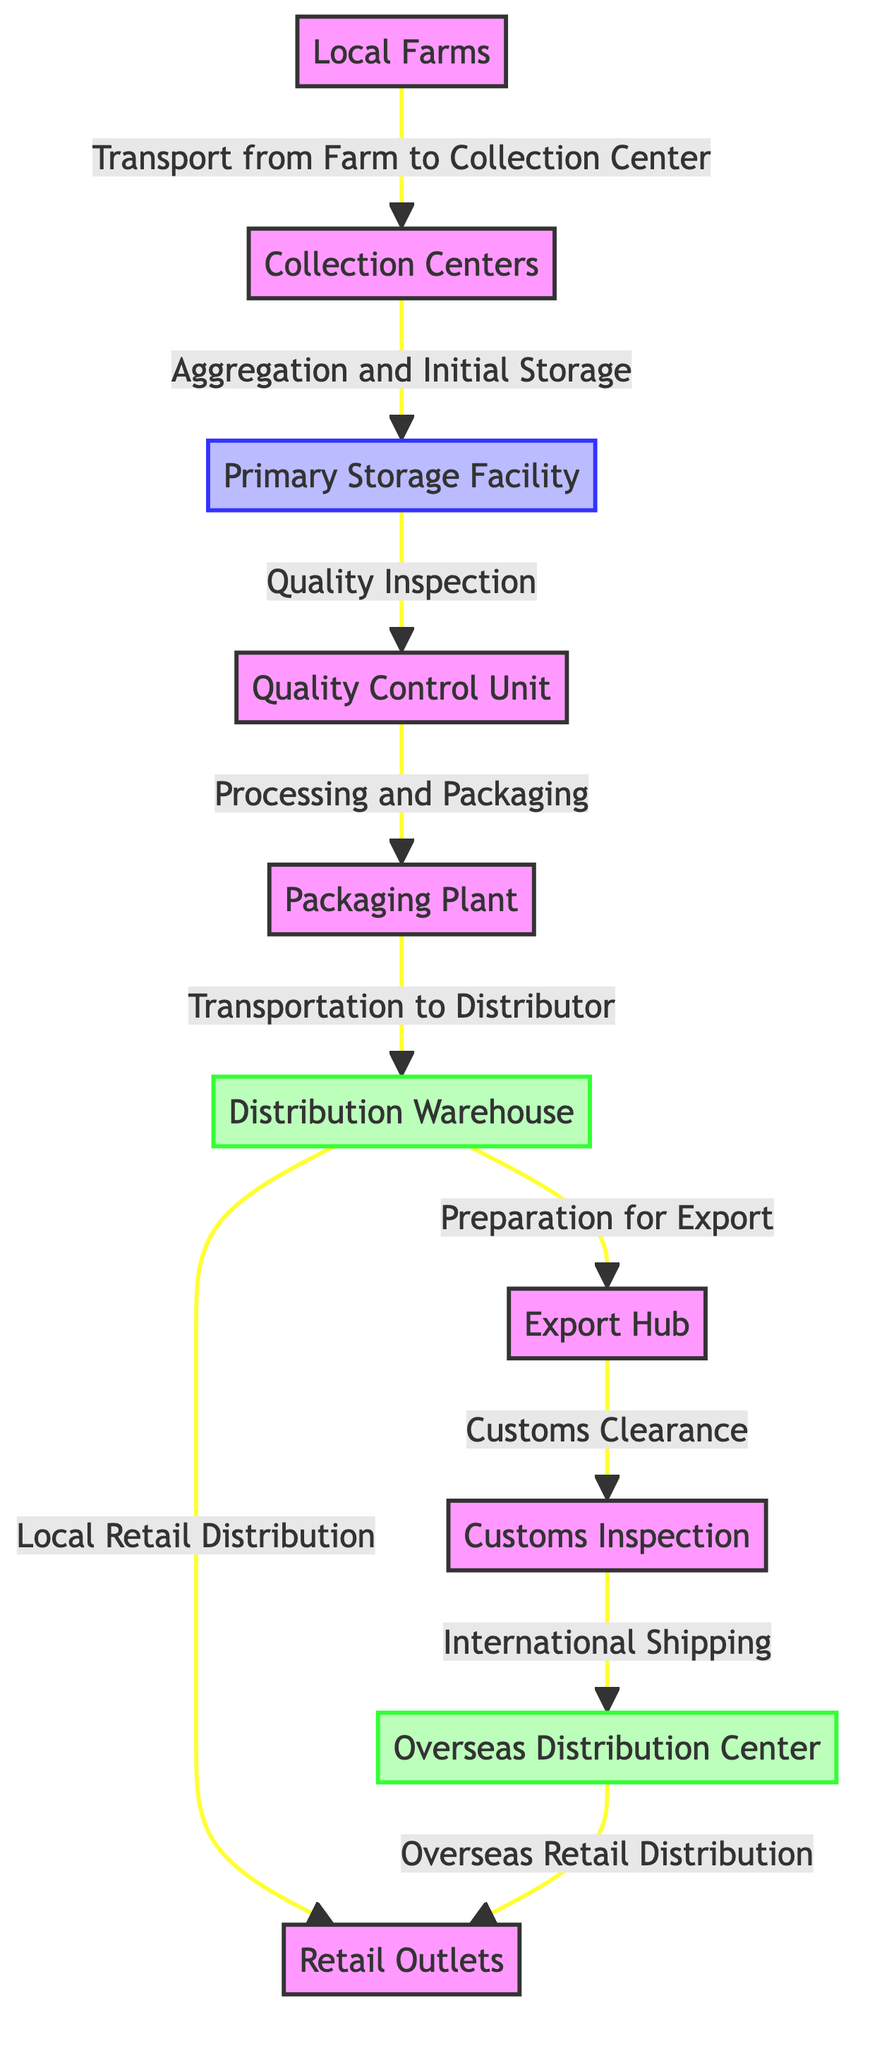What is the first node in the flow? The diagram starts at the first node labeled "Local Farms," which is where the sourcing of tropical fruits begins.
Answer: Local Farms How many nodes are in the diagram? By counting all the distinct locations listed in the diagram, there are a total of ten nodes present.
Answer: 10 What type of facility is the Primary Storage Facility? The Primary Storage Facility is categorized as a storage facility, which is indicated by the specific styling applied to that node in the diagram.
Answer: Storage Which node follows the Quality Control Unit? After the Quality Control Unit, the next node in the flow is the Packaging Plant, indicating that products are then processed for packaging.
Answer: Packaging Plant What is the relationship between the Distribution Warehouse and the Retail Outlets? The relationship shows that the Distribution Warehouse leads directly to Local Retail Distribution, supplying the Retail Outlets with products.
Answer: Local Retail Distribution Which two nodes connect to the Distribution Warehouse? The Distribution Warehouse receives products from the Packaging Plant and also sends products to the Retail Outlets and Export Hub.
Answer: Packaging Plant and Export Hub What is the last step before International Shipping? Before products can be shipped internationally, they must pass through Customs Inspection, which is the last step in that route.
Answer: Customs Inspection Which node is responsible for quality inspection? The Quality Control Unit is designated for quality inspection, ensuring that products meet certain standards before proceeding to the next phase.
Answer: Quality Control Unit Which nodes are involved in the export process? The nodes involved in the export process are the Export Hub, Customs Inspection, and Overseas Distribution Center, indicating the flow for exporting products.
Answer: Export Hub, Customs Inspection, Overseas Distribution Center What is the final destination for the Overseas Retail Distribution? The endpoint of Overseas Retail Distribution is the Retail Outlets, showing that products ultimately reach the consumers in those locations.
Answer: Retail Outlets 